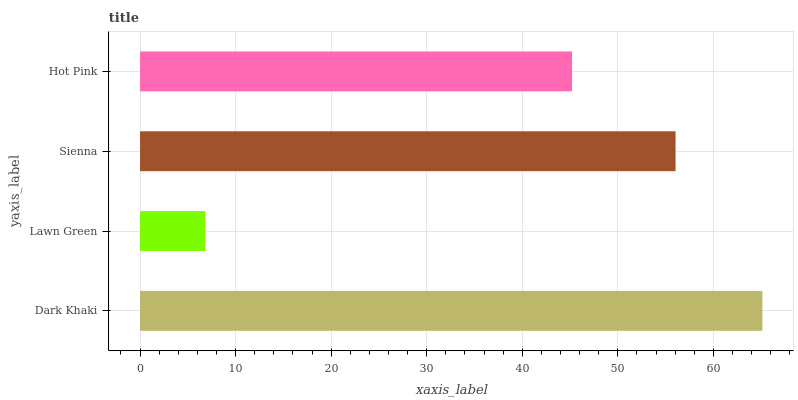Is Lawn Green the minimum?
Answer yes or no. Yes. Is Dark Khaki the maximum?
Answer yes or no. Yes. Is Sienna the minimum?
Answer yes or no. No. Is Sienna the maximum?
Answer yes or no. No. Is Sienna greater than Lawn Green?
Answer yes or no. Yes. Is Lawn Green less than Sienna?
Answer yes or no. Yes. Is Lawn Green greater than Sienna?
Answer yes or no. No. Is Sienna less than Lawn Green?
Answer yes or no. No. Is Sienna the high median?
Answer yes or no. Yes. Is Hot Pink the low median?
Answer yes or no. Yes. Is Lawn Green the high median?
Answer yes or no. No. Is Lawn Green the low median?
Answer yes or no. No. 